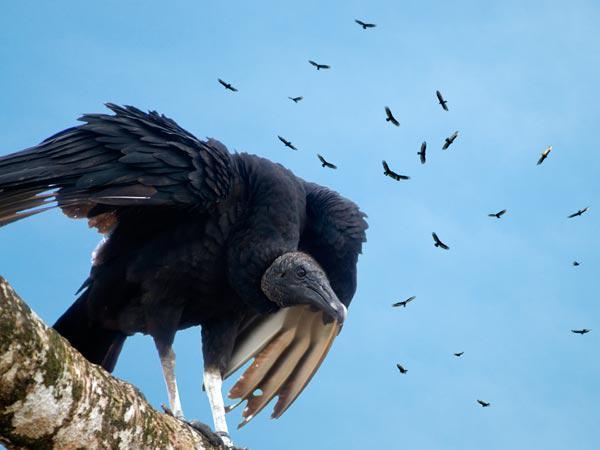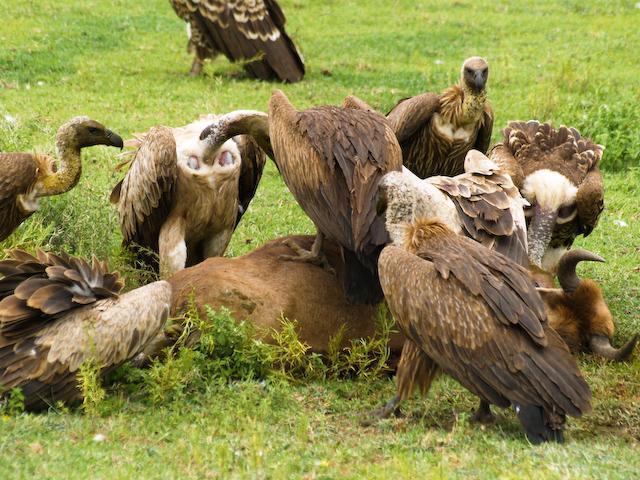The first image is the image on the left, the second image is the image on the right. Analyze the images presented: Is the assertion "There are no more than five birds in one of the images." valid? Answer yes or no. No. 